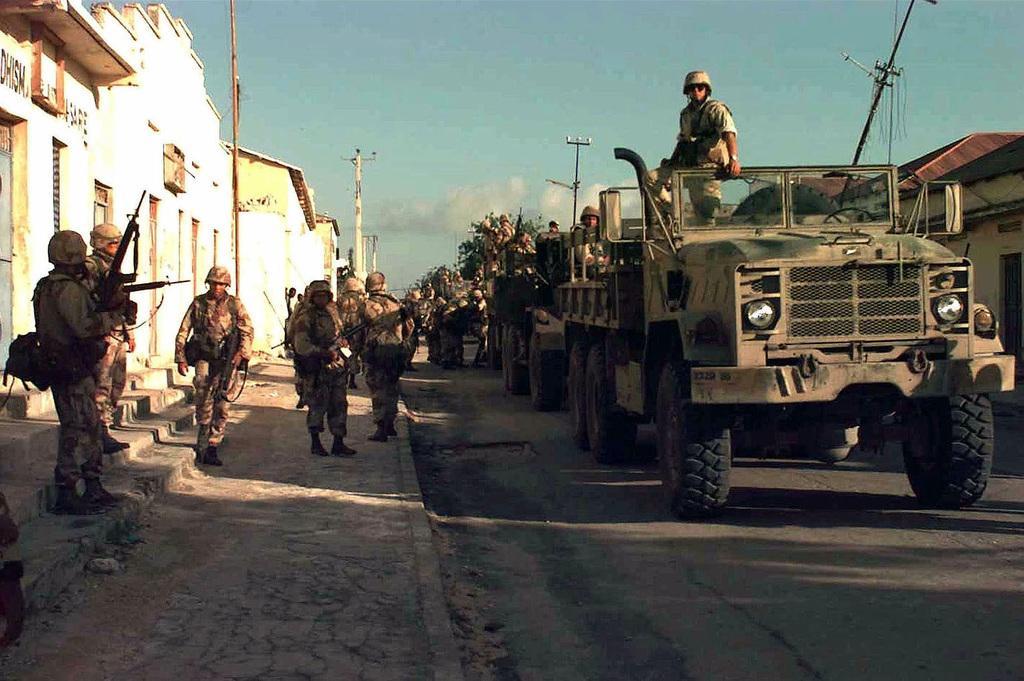Describe this image in one or two sentences. In this image I can see the road. On the road there are many vehicles and some people inside the vehicles. To the side I can see few more people standing and wearing the military uniforms. I can see the houses to the side of the road. In the back I can see the clouds and the blue sky. 